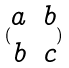Convert formula to latex. <formula><loc_0><loc_0><loc_500><loc_500>( \begin{matrix} a & b \\ b & c \end{matrix} )</formula> 